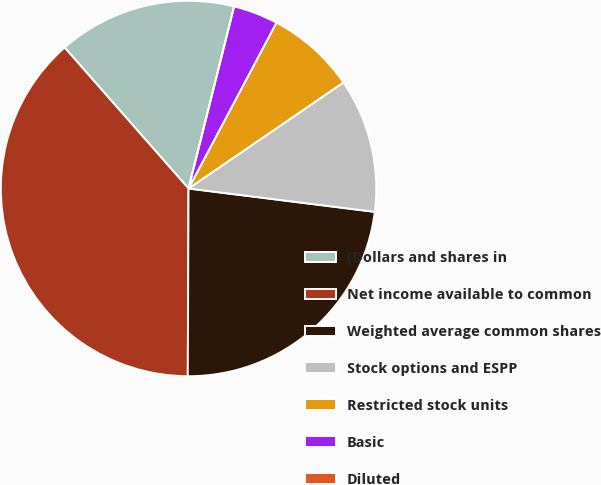<chart> <loc_0><loc_0><loc_500><loc_500><pie_chart><fcel>(Dollars and shares in<fcel>Net income available to common<fcel>Weighted average common shares<fcel>Stock options and ESPP<fcel>Restricted stock units<fcel>Basic<fcel>Diluted<nl><fcel>15.38%<fcel>38.46%<fcel>23.08%<fcel>11.54%<fcel>7.69%<fcel>3.85%<fcel>0.0%<nl></chart> 